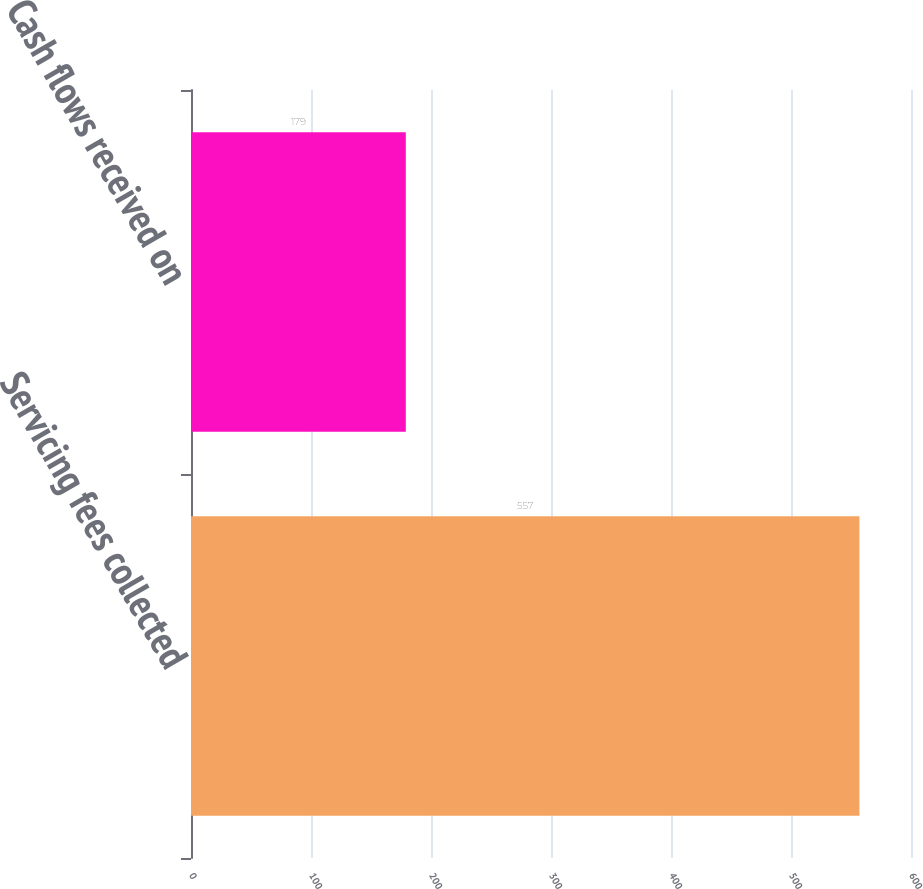<chart> <loc_0><loc_0><loc_500><loc_500><bar_chart><fcel>Servicing fees collected<fcel>Cash flows received on<nl><fcel>557<fcel>179<nl></chart> 